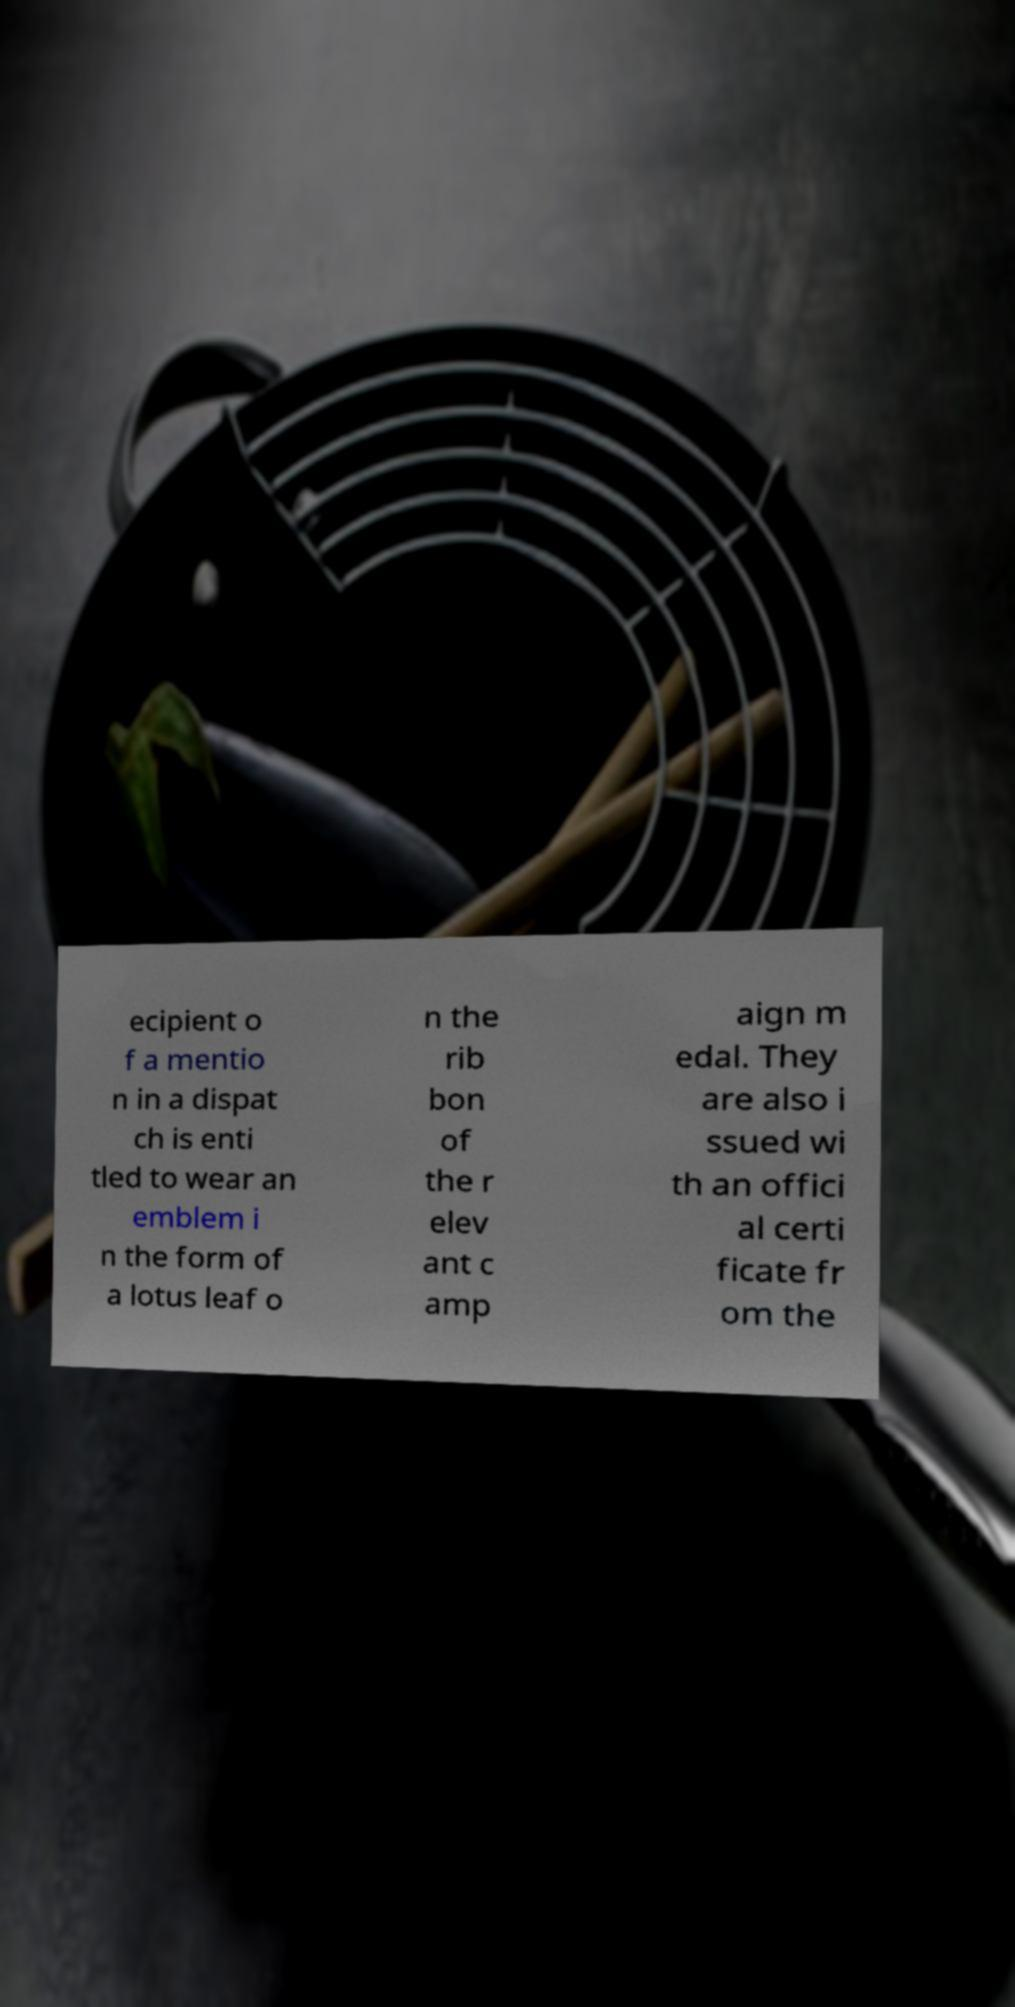Can you accurately transcribe the text from the provided image for me? ecipient o f a mentio n in a dispat ch is enti tled to wear an emblem i n the form of a lotus leaf o n the rib bon of the r elev ant c amp aign m edal. They are also i ssued wi th an offici al certi ficate fr om the 